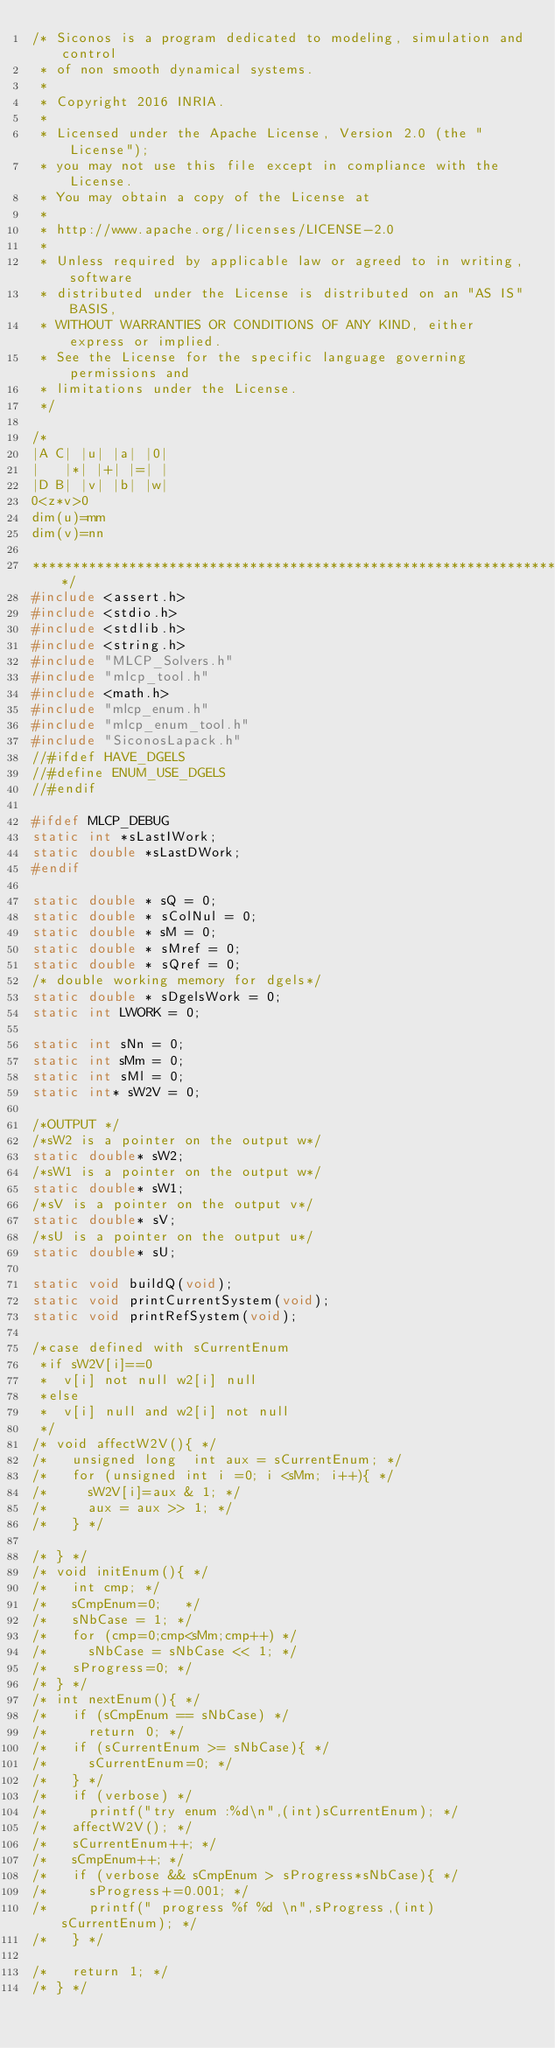Convert code to text. <code><loc_0><loc_0><loc_500><loc_500><_C_>/* Siconos is a program dedicated to modeling, simulation and control
 * of non smooth dynamical systems.
 *
 * Copyright 2016 INRIA.
 *
 * Licensed under the Apache License, Version 2.0 (the "License");
 * you may not use this file except in compliance with the License.
 * You may obtain a copy of the License at
 *
 * http://www.apache.org/licenses/LICENSE-2.0
 *
 * Unless required by applicable law or agreed to in writing, software
 * distributed under the License is distributed on an "AS IS" BASIS,
 * WITHOUT WARRANTIES OR CONDITIONS OF ANY KIND, either express or implied.
 * See the License for the specific language governing permissions and
 * limitations under the License.
 */

/*
|A C| |u| |a| |0|
|   |*| |+| |=| |
|D B| |v| |b| |w|
0<z*v>0
dim(u)=mm
dim(v)=nn

**************************************************************************/
#include <assert.h>
#include <stdio.h>
#include <stdlib.h>
#include <string.h>
#include "MLCP_Solvers.h"
#include "mlcp_tool.h"
#include <math.h>
#include "mlcp_enum.h"
#include "mlcp_enum_tool.h"
#include "SiconosLapack.h"
//#ifdef HAVE_DGELS
//#define ENUM_USE_DGELS
//#endif

#ifdef MLCP_DEBUG
static int *sLastIWork;
static double *sLastDWork;
#endif

static double * sQ = 0;
static double * sColNul = 0;
static double * sM = 0;
static double * sMref = 0;
static double * sQref = 0;
/* double working memory for dgels*/
static double * sDgelsWork = 0;
static int LWORK = 0;

static int sNn = 0;
static int sMm = 0;
static int sMl = 0;
static int* sW2V = 0;

/*OUTPUT */
/*sW2 is a pointer on the output w*/
static double* sW2;
/*sW1 is a pointer on the output w*/
static double* sW1;
/*sV is a pointer on the output v*/
static double* sV;
/*sU is a pointer on the output u*/
static double* sU;

static void buildQ(void);
static void printCurrentSystem(void);
static void printRefSystem(void);

/*case defined with sCurrentEnum
 *if sW2V[i]==0
 *  v[i] not null w2[i] null
 *else
 *  v[i] null and w2[i] not null
 */
/* void affectW2V(){ */
/*   unsigned long  int aux = sCurrentEnum; */
/*   for (unsigned int i =0; i <sMm; i++){ */
/*     sW2V[i]=aux & 1; */
/*     aux = aux >> 1; */
/*   } */

/* } */
/* void initEnum(){ */
/*   int cmp; */
/*   sCmpEnum=0;   */
/*   sNbCase = 1; */
/*   for (cmp=0;cmp<sMm;cmp++) */
/*     sNbCase = sNbCase << 1; */
/*   sProgress=0; */
/* } */
/* int nextEnum(){ */
/*   if (sCmpEnum == sNbCase) */
/*     return 0; */
/*   if (sCurrentEnum >= sNbCase){ */
/*     sCurrentEnum=0; */
/*   } */
/*   if (verbose) */
/*     printf("try enum :%d\n",(int)sCurrentEnum); */
/*   affectW2V(); */
/*   sCurrentEnum++; */
/*   sCmpEnum++; */
/*   if (verbose && sCmpEnum > sProgress*sNbCase){ */
/*     sProgress+=0.001; */
/*     printf(" progress %f %d \n",sProgress,(int) sCurrentEnum); */
/*   } */

/*   return 1; */
/* } */

</code> 